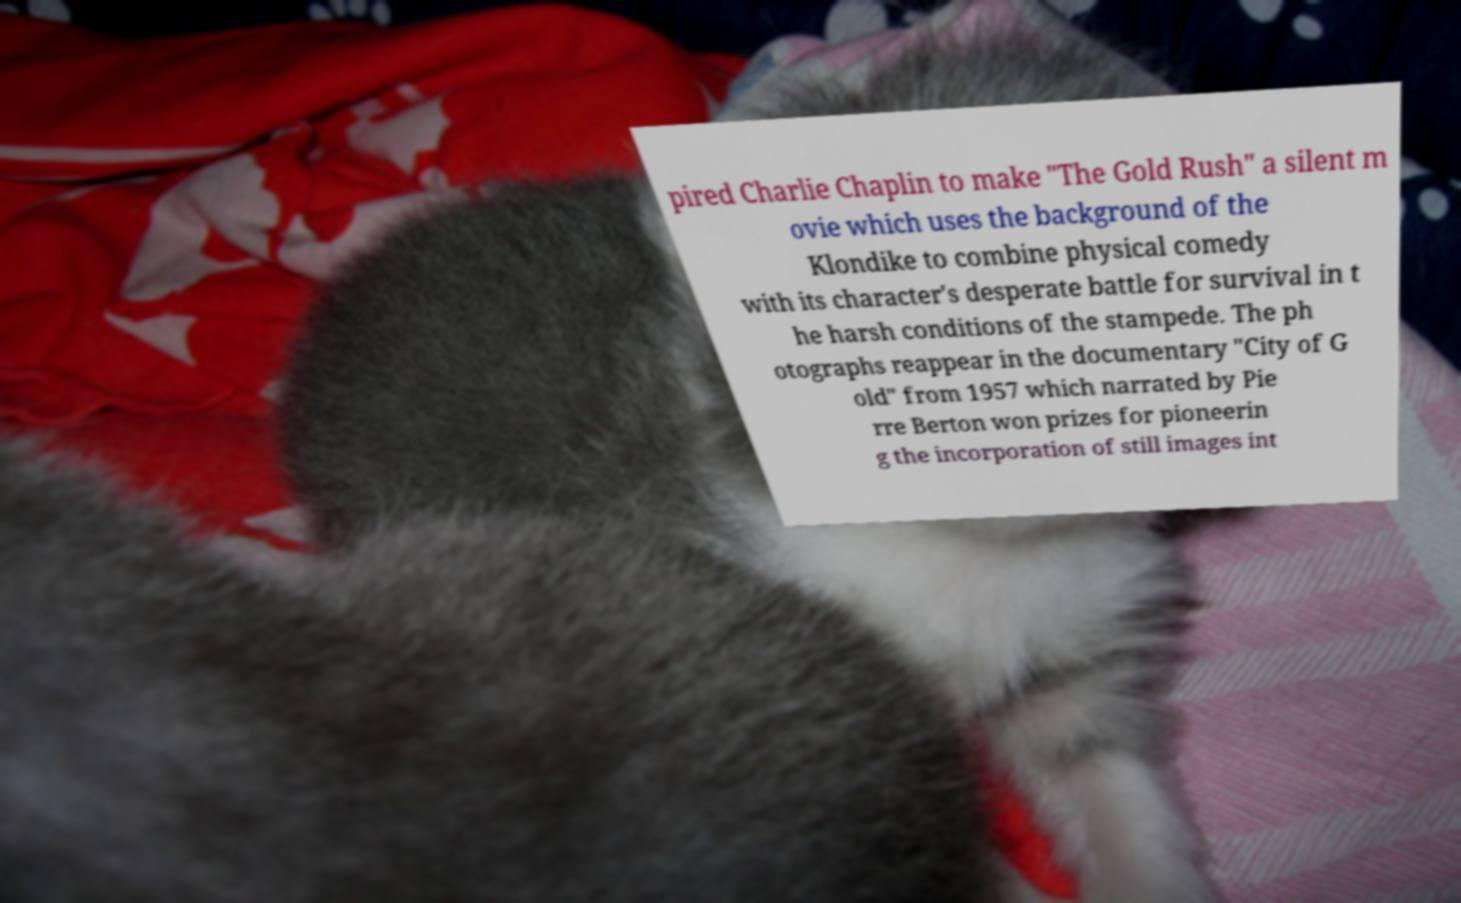Could you extract and type out the text from this image? pired Charlie Chaplin to make "The Gold Rush" a silent m ovie which uses the background of the Klondike to combine physical comedy with its character's desperate battle for survival in t he harsh conditions of the stampede. The ph otographs reappear in the documentary "City of G old" from 1957 which narrated by Pie rre Berton won prizes for pioneerin g the incorporation of still images int 